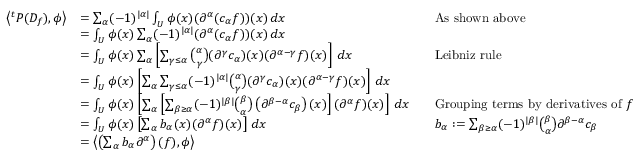Convert formula to latex. <formula><loc_0><loc_0><loc_500><loc_500>{ \begin{array} { r l r l } { \left \langle ^ { t } P ( D _ { f } ) , \phi \right \rangle } & { = \sum _ { \alpha } ( - 1 ) ^ { | \alpha | } \int _ { U } \phi ( x ) ( \partial ^ { \alpha } ( c _ { \alpha } f ) ) ( x ) \, d x } & & { A s s h o w n a b o v e } \\ & { = \int _ { U } \phi ( x ) \sum _ { \alpha } ( - 1 ) ^ { | \alpha | } ( \partial ^ { \alpha } ( c _ { \alpha } f ) ) ( x ) \, d x } \\ & { = \int _ { U } \phi ( x ) \sum _ { \alpha } \left [ \sum _ { \gamma \leq \alpha } { \binom { \alpha } { \gamma } } ( \partial ^ { \gamma } c _ { \alpha } ) ( x ) ( \partial ^ { \alpha - \gamma } f ) ( x ) \right ] \, d x } & & { L e i b n i z r u l e } \\ & { = \int _ { U } \phi ( x ) \left [ \sum _ { \alpha } \sum _ { \gamma \leq \alpha } ( - 1 ) ^ { | \alpha | } { \binom { \alpha } { \gamma } } ( \partial ^ { \gamma } c _ { \alpha } ) ( x ) ( \partial ^ { \alpha - \gamma } f ) ( x ) \right ] \, d x } \\ & { = \int _ { U } \phi ( x ) \left [ \sum _ { \alpha } \left [ \sum _ { \beta \geq \alpha } ( - 1 ) ^ { | \beta | } { \binom { \beta } { \alpha } } \left ( \partial ^ { \beta - \alpha } c _ { \beta } \right ) ( x ) \right ] ( \partial ^ { \alpha } f ) ( x ) \right ] \, d x } & & { { G r o u p i n g t e r m s b y d e r i v a t i v e s o f } f } \\ & { = \int _ { U } \phi ( x ) \left [ \sum _ { \alpha } b _ { \alpha } ( x ) ( \partial ^ { \alpha } f ) ( x ) \right ] \, d x } & & { b _ { \alpha } \colon = \sum _ { \beta \geq \alpha } ( - 1 ) ^ { | \beta | } { \binom { \beta } { \alpha } } \partial ^ { \beta - \alpha } c _ { \beta } } \\ & { = \left \langle \left ( \sum _ { \alpha } b _ { \alpha } \partial ^ { \alpha } \right ) ( f ) , \phi \right \rangle } \end{array} }</formula> 